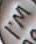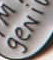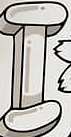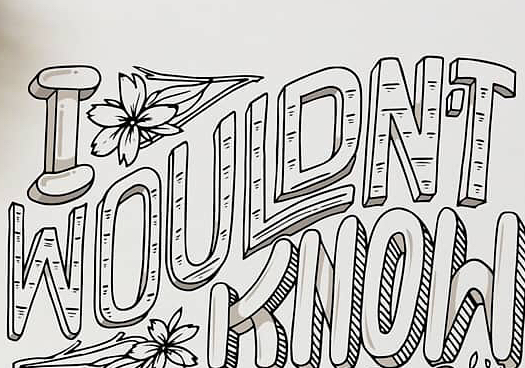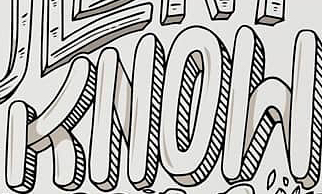What text appears in these images from left to right, separated by a semicolon? I'M; geNi; I; WOULDN'T; KNOW 